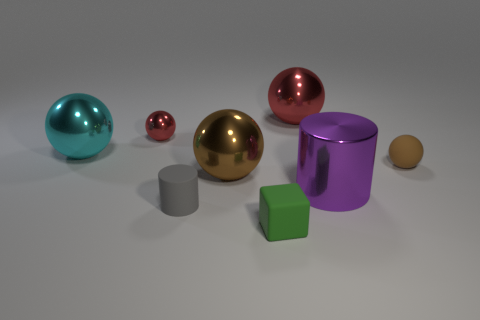Subtract all small rubber balls. How many balls are left? 4 Subtract all cyan spheres. How many spheres are left? 4 Subtract 1 spheres. How many spheres are left? 4 Add 2 red metal blocks. How many objects exist? 10 Subtract all balls. How many objects are left? 3 Subtract all purple spheres. Subtract all blue blocks. How many spheres are left? 5 Subtract all blue cylinders. How many brown spheres are left? 2 Subtract all big things. Subtract all brown balls. How many objects are left? 2 Add 6 small rubber spheres. How many small rubber spheres are left? 7 Add 4 big red metallic things. How many big red metallic things exist? 5 